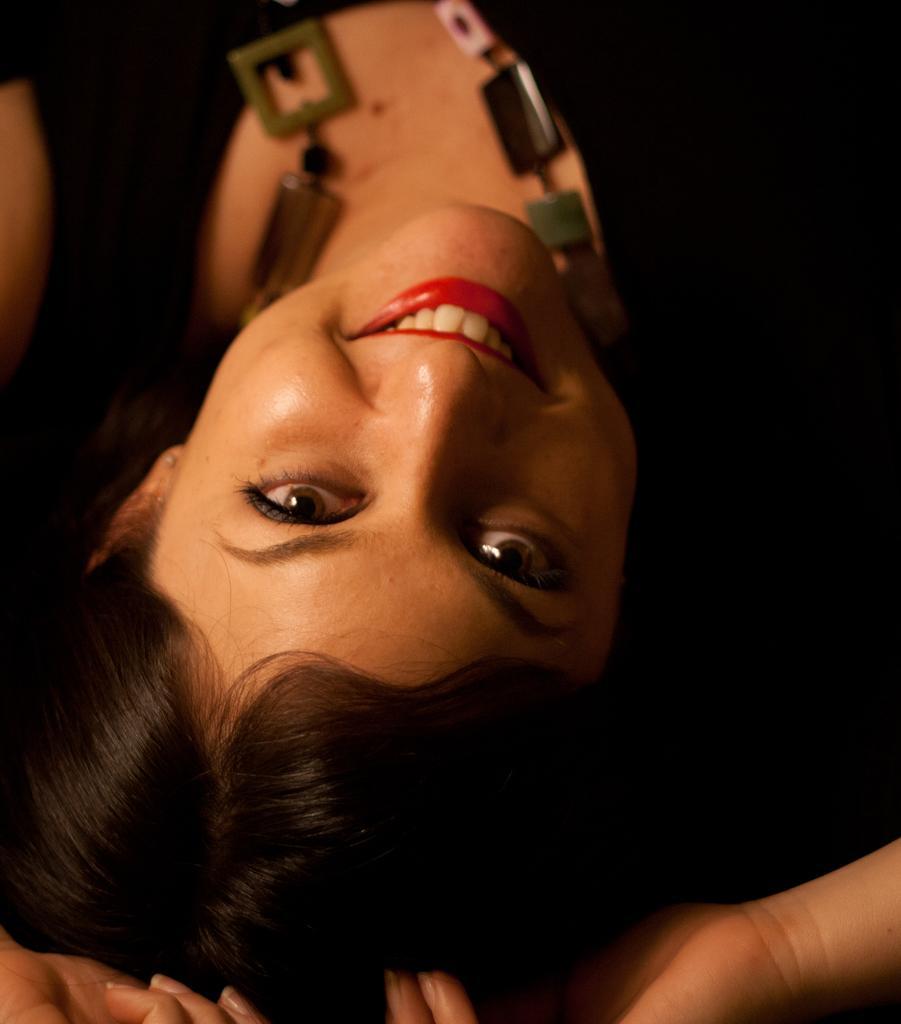Could you give a brief overview of what you see in this image? In the image there is a woman, she is smiling and she is wearing a necklace and the background of the woman is dark. 